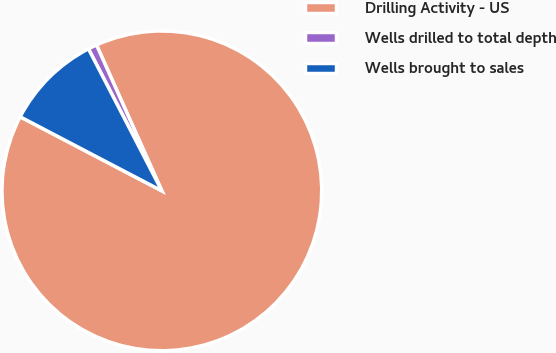<chart> <loc_0><loc_0><loc_500><loc_500><pie_chart><fcel>Drilling Activity - US<fcel>Wells drilled to total depth<fcel>Wells brought to sales<nl><fcel>89.38%<fcel>0.89%<fcel>9.74%<nl></chart> 